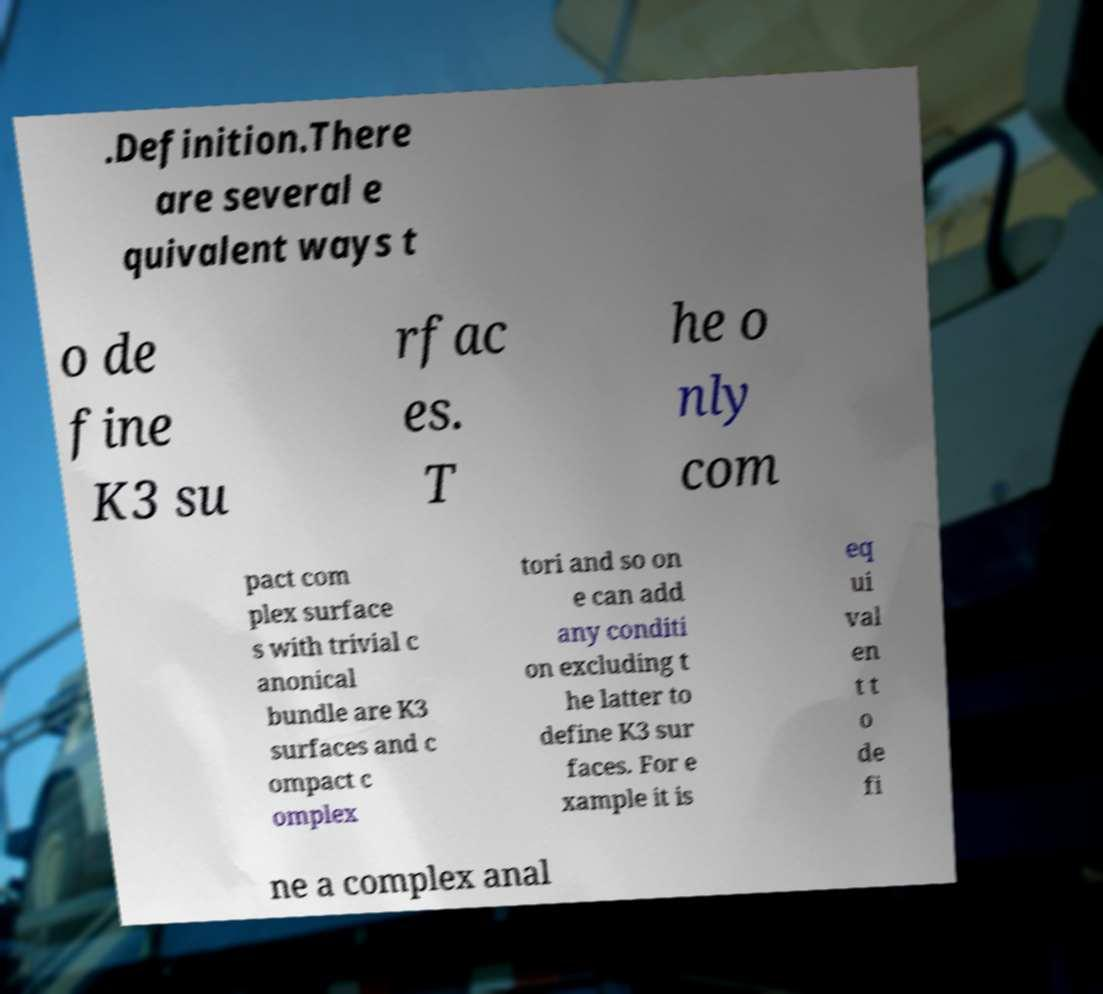I need the written content from this picture converted into text. Can you do that? .Definition.There are several e quivalent ways t o de fine K3 su rfac es. T he o nly com pact com plex surface s with trivial c anonical bundle are K3 surfaces and c ompact c omplex tori and so on e can add any conditi on excluding t he latter to define K3 sur faces. For e xample it is eq ui val en t t o de fi ne a complex anal 